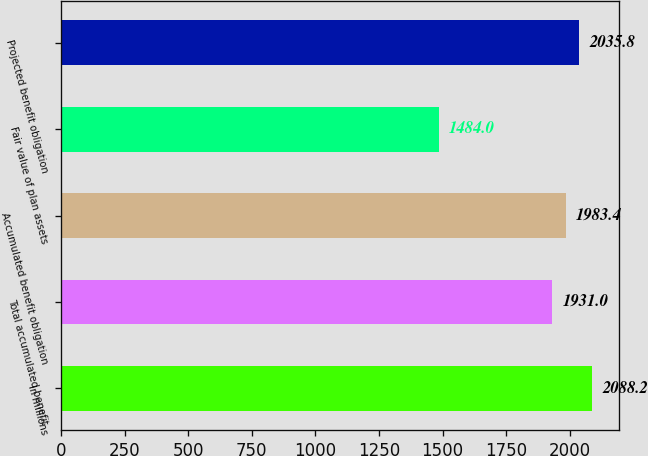Convert chart to OTSL. <chart><loc_0><loc_0><loc_500><loc_500><bar_chart><fcel>In millions<fcel>Total accumulated benefit<fcel>Accumulated benefit obligation<fcel>Fair value of plan assets<fcel>Projected benefit obligation<nl><fcel>2088.2<fcel>1931<fcel>1983.4<fcel>1484<fcel>2035.8<nl></chart> 